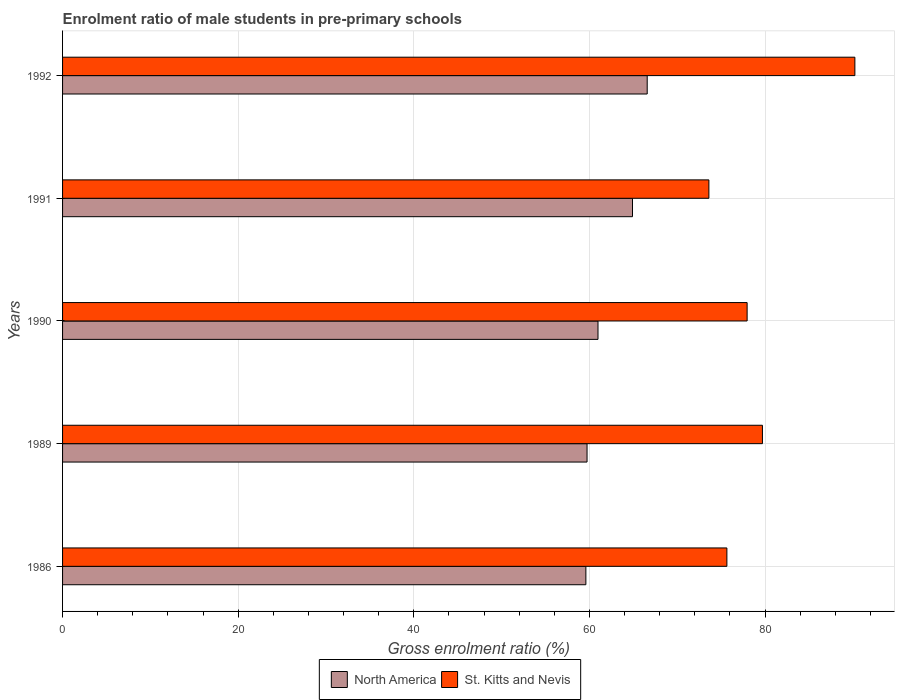How many groups of bars are there?
Your answer should be compact. 5. Are the number of bars per tick equal to the number of legend labels?
Provide a short and direct response. Yes. Are the number of bars on each tick of the Y-axis equal?
Offer a terse response. Yes. How many bars are there on the 2nd tick from the top?
Give a very brief answer. 2. How many bars are there on the 4th tick from the bottom?
Give a very brief answer. 2. What is the label of the 3rd group of bars from the top?
Offer a terse response. 1990. In how many cases, is the number of bars for a given year not equal to the number of legend labels?
Keep it short and to the point. 0. What is the enrolment ratio of male students in pre-primary schools in St. Kitts and Nevis in 1990?
Your answer should be compact. 77.95. Across all years, what is the maximum enrolment ratio of male students in pre-primary schools in North America?
Your response must be concise. 66.57. Across all years, what is the minimum enrolment ratio of male students in pre-primary schools in St. Kitts and Nevis?
Keep it short and to the point. 73.6. In which year was the enrolment ratio of male students in pre-primary schools in St. Kitts and Nevis maximum?
Keep it short and to the point. 1992. In which year was the enrolment ratio of male students in pre-primary schools in St. Kitts and Nevis minimum?
Offer a terse response. 1991. What is the total enrolment ratio of male students in pre-primary schools in St. Kitts and Nevis in the graph?
Your response must be concise. 397.11. What is the difference between the enrolment ratio of male students in pre-primary schools in St. Kitts and Nevis in 1989 and that in 1992?
Your answer should be very brief. -10.53. What is the difference between the enrolment ratio of male students in pre-primary schools in North America in 1989 and the enrolment ratio of male students in pre-primary schools in St. Kitts and Nevis in 1986?
Your response must be concise. -15.92. What is the average enrolment ratio of male students in pre-primary schools in St. Kitts and Nevis per year?
Ensure brevity in your answer.  79.42. In the year 1992, what is the difference between the enrolment ratio of male students in pre-primary schools in St. Kitts and Nevis and enrolment ratio of male students in pre-primary schools in North America?
Offer a terse response. 23.65. In how many years, is the enrolment ratio of male students in pre-primary schools in St. Kitts and Nevis greater than 56 %?
Keep it short and to the point. 5. What is the ratio of the enrolment ratio of male students in pre-primary schools in North America in 1990 to that in 1991?
Your answer should be very brief. 0.94. What is the difference between the highest and the second highest enrolment ratio of male students in pre-primary schools in St. Kitts and Nevis?
Your response must be concise. 10.53. What is the difference between the highest and the lowest enrolment ratio of male students in pre-primary schools in North America?
Make the answer very short. 6.98. What does the 1st bar from the top in 1991 represents?
Give a very brief answer. St. Kitts and Nevis. What does the 2nd bar from the bottom in 1990 represents?
Offer a very short reply. St. Kitts and Nevis. Are all the bars in the graph horizontal?
Ensure brevity in your answer.  Yes. How many years are there in the graph?
Offer a terse response. 5. Does the graph contain any zero values?
Your response must be concise. No. Does the graph contain grids?
Your response must be concise. Yes. Where does the legend appear in the graph?
Provide a succinct answer. Bottom center. How are the legend labels stacked?
Ensure brevity in your answer.  Horizontal. What is the title of the graph?
Provide a short and direct response. Enrolment ratio of male students in pre-primary schools. What is the label or title of the X-axis?
Ensure brevity in your answer.  Gross enrolment ratio (%). What is the label or title of the Y-axis?
Your response must be concise. Years. What is the Gross enrolment ratio (%) of North America in 1986?
Make the answer very short. 59.59. What is the Gross enrolment ratio (%) in St. Kitts and Nevis in 1986?
Ensure brevity in your answer.  75.65. What is the Gross enrolment ratio (%) in North America in 1989?
Your answer should be compact. 59.72. What is the Gross enrolment ratio (%) in St. Kitts and Nevis in 1989?
Provide a short and direct response. 79.69. What is the Gross enrolment ratio (%) in North America in 1990?
Your answer should be very brief. 60.97. What is the Gross enrolment ratio (%) of St. Kitts and Nevis in 1990?
Your response must be concise. 77.95. What is the Gross enrolment ratio (%) in North America in 1991?
Provide a succinct answer. 64.9. What is the Gross enrolment ratio (%) in St. Kitts and Nevis in 1991?
Your answer should be very brief. 73.6. What is the Gross enrolment ratio (%) of North America in 1992?
Offer a very short reply. 66.57. What is the Gross enrolment ratio (%) of St. Kitts and Nevis in 1992?
Make the answer very short. 90.22. Across all years, what is the maximum Gross enrolment ratio (%) in North America?
Your response must be concise. 66.57. Across all years, what is the maximum Gross enrolment ratio (%) in St. Kitts and Nevis?
Give a very brief answer. 90.22. Across all years, what is the minimum Gross enrolment ratio (%) in North America?
Keep it short and to the point. 59.59. Across all years, what is the minimum Gross enrolment ratio (%) of St. Kitts and Nevis?
Ensure brevity in your answer.  73.6. What is the total Gross enrolment ratio (%) in North America in the graph?
Make the answer very short. 311.75. What is the total Gross enrolment ratio (%) in St. Kitts and Nevis in the graph?
Give a very brief answer. 397.11. What is the difference between the Gross enrolment ratio (%) of North America in 1986 and that in 1989?
Make the answer very short. -0.13. What is the difference between the Gross enrolment ratio (%) in St. Kitts and Nevis in 1986 and that in 1989?
Give a very brief answer. -4.05. What is the difference between the Gross enrolment ratio (%) in North America in 1986 and that in 1990?
Offer a very short reply. -1.38. What is the difference between the Gross enrolment ratio (%) of St. Kitts and Nevis in 1986 and that in 1990?
Offer a very short reply. -2.3. What is the difference between the Gross enrolment ratio (%) of North America in 1986 and that in 1991?
Ensure brevity in your answer.  -5.31. What is the difference between the Gross enrolment ratio (%) of St. Kitts and Nevis in 1986 and that in 1991?
Offer a terse response. 2.05. What is the difference between the Gross enrolment ratio (%) in North America in 1986 and that in 1992?
Give a very brief answer. -6.98. What is the difference between the Gross enrolment ratio (%) of St. Kitts and Nevis in 1986 and that in 1992?
Your answer should be very brief. -14.57. What is the difference between the Gross enrolment ratio (%) of North America in 1989 and that in 1990?
Make the answer very short. -1.25. What is the difference between the Gross enrolment ratio (%) of St. Kitts and Nevis in 1989 and that in 1990?
Your answer should be compact. 1.74. What is the difference between the Gross enrolment ratio (%) in North America in 1989 and that in 1991?
Offer a terse response. -5.18. What is the difference between the Gross enrolment ratio (%) of St. Kitts and Nevis in 1989 and that in 1991?
Ensure brevity in your answer.  6.1. What is the difference between the Gross enrolment ratio (%) of North America in 1989 and that in 1992?
Offer a very short reply. -6.85. What is the difference between the Gross enrolment ratio (%) in St. Kitts and Nevis in 1989 and that in 1992?
Your answer should be very brief. -10.53. What is the difference between the Gross enrolment ratio (%) in North America in 1990 and that in 1991?
Your answer should be compact. -3.93. What is the difference between the Gross enrolment ratio (%) in St. Kitts and Nevis in 1990 and that in 1991?
Your answer should be very brief. 4.35. What is the difference between the Gross enrolment ratio (%) in North America in 1990 and that in 1992?
Your answer should be very brief. -5.6. What is the difference between the Gross enrolment ratio (%) in St. Kitts and Nevis in 1990 and that in 1992?
Keep it short and to the point. -12.27. What is the difference between the Gross enrolment ratio (%) in North America in 1991 and that in 1992?
Make the answer very short. -1.67. What is the difference between the Gross enrolment ratio (%) of St. Kitts and Nevis in 1991 and that in 1992?
Offer a terse response. -16.62. What is the difference between the Gross enrolment ratio (%) in North America in 1986 and the Gross enrolment ratio (%) in St. Kitts and Nevis in 1989?
Offer a very short reply. -20.11. What is the difference between the Gross enrolment ratio (%) of North America in 1986 and the Gross enrolment ratio (%) of St. Kitts and Nevis in 1990?
Give a very brief answer. -18.36. What is the difference between the Gross enrolment ratio (%) of North America in 1986 and the Gross enrolment ratio (%) of St. Kitts and Nevis in 1991?
Your response must be concise. -14.01. What is the difference between the Gross enrolment ratio (%) of North America in 1986 and the Gross enrolment ratio (%) of St. Kitts and Nevis in 1992?
Keep it short and to the point. -30.63. What is the difference between the Gross enrolment ratio (%) in North America in 1989 and the Gross enrolment ratio (%) in St. Kitts and Nevis in 1990?
Provide a short and direct response. -18.23. What is the difference between the Gross enrolment ratio (%) of North America in 1989 and the Gross enrolment ratio (%) of St. Kitts and Nevis in 1991?
Offer a very short reply. -13.87. What is the difference between the Gross enrolment ratio (%) of North America in 1989 and the Gross enrolment ratio (%) of St. Kitts and Nevis in 1992?
Your answer should be compact. -30.5. What is the difference between the Gross enrolment ratio (%) of North America in 1990 and the Gross enrolment ratio (%) of St. Kitts and Nevis in 1991?
Your answer should be very brief. -12.63. What is the difference between the Gross enrolment ratio (%) of North America in 1990 and the Gross enrolment ratio (%) of St. Kitts and Nevis in 1992?
Your response must be concise. -29.25. What is the difference between the Gross enrolment ratio (%) of North America in 1991 and the Gross enrolment ratio (%) of St. Kitts and Nevis in 1992?
Make the answer very short. -25.32. What is the average Gross enrolment ratio (%) of North America per year?
Give a very brief answer. 62.35. What is the average Gross enrolment ratio (%) in St. Kitts and Nevis per year?
Your answer should be compact. 79.42. In the year 1986, what is the difference between the Gross enrolment ratio (%) in North America and Gross enrolment ratio (%) in St. Kitts and Nevis?
Your answer should be very brief. -16.06. In the year 1989, what is the difference between the Gross enrolment ratio (%) in North America and Gross enrolment ratio (%) in St. Kitts and Nevis?
Ensure brevity in your answer.  -19.97. In the year 1990, what is the difference between the Gross enrolment ratio (%) in North America and Gross enrolment ratio (%) in St. Kitts and Nevis?
Give a very brief answer. -16.98. In the year 1991, what is the difference between the Gross enrolment ratio (%) in North America and Gross enrolment ratio (%) in St. Kitts and Nevis?
Give a very brief answer. -8.7. In the year 1992, what is the difference between the Gross enrolment ratio (%) in North America and Gross enrolment ratio (%) in St. Kitts and Nevis?
Your answer should be very brief. -23.65. What is the ratio of the Gross enrolment ratio (%) of North America in 1986 to that in 1989?
Provide a succinct answer. 1. What is the ratio of the Gross enrolment ratio (%) in St. Kitts and Nevis in 1986 to that in 1989?
Your answer should be very brief. 0.95. What is the ratio of the Gross enrolment ratio (%) in North America in 1986 to that in 1990?
Offer a very short reply. 0.98. What is the ratio of the Gross enrolment ratio (%) of St. Kitts and Nevis in 1986 to that in 1990?
Offer a terse response. 0.97. What is the ratio of the Gross enrolment ratio (%) in North America in 1986 to that in 1991?
Offer a terse response. 0.92. What is the ratio of the Gross enrolment ratio (%) of St. Kitts and Nevis in 1986 to that in 1991?
Give a very brief answer. 1.03. What is the ratio of the Gross enrolment ratio (%) of North America in 1986 to that in 1992?
Offer a terse response. 0.9. What is the ratio of the Gross enrolment ratio (%) of St. Kitts and Nevis in 1986 to that in 1992?
Ensure brevity in your answer.  0.84. What is the ratio of the Gross enrolment ratio (%) of North America in 1989 to that in 1990?
Offer a terse response. 0.98. What is the ratio of the Gross enrolment ratio (%) of St. Kitts and Nevis in 1989 to that in 1990?
Your response must be concise. 1.02. What is the ratio of the Gross enrolment ratio (%) in North America in 1989 to that in 1991?
Provide a succinct answer. 0.92. What is the ratio of the Gross enrolment ratio (%) of St. Kitts and Nevis in 1989 to that in 1991?
Your answer should be very brief. 1.08. What is the ratio of the Gross enrolment ratio (%) of North America in 1989 to that in 1992?
Your answer should be compact. 0.9. What is the ratio of the Gross enrolment ratio (%) in St. Kitts and Nevis in 1989 to that in 1992?
Provide a succinct answer. 0.88. What is the ratio of the Gross enrolment ratio (%) of North America in 1990 to that in 1991?
Make the answer very short. 0.94. What is the ratio of the Gross enrolment ratio (%) in St. Kitts and Nevis in 1990 to that in 1991?
Provide a succinct answer. 1.06. What is the ratio of the Gross enrolment ratio (%) in North America in 1990 to that in 1992?
Offer a very short reply. 0.92. What is the ratio of the Gross enrolment ratio (%) in St. Kitts and Nevis in 1990 to that in 1992?
Your answer should be very brief. 0.86. What is the ratio of the Gross enrolment ratio (%) in North America in 1991 to that in 1992?
Give a very brief answer. 0.97. What is the ratio of the Gross enrolment ratio (%) in St. Kitts and Nevis in 1991 to that in 1992?
Keep it short and to the point. 0.82. What is the difference between the highest and the second highest Gross enrolment ratio (%) of North America?
Your answer should be very brief. 1.67. What is the difference between the highest and the second highest Gross enrolment ratio (%) in St. Kitts and Nevis?
Offer a terse response. 10.53. What is the difference between the highest and the lowest Gross enrolment ratio (%) of North America?
Ensure brevity in your answer.  6.98. What is the difference between the highest and the lowest Gross enrolment ratio (%) of St. Kitts and Nevis?
Your answer should be compact. 16.62. 